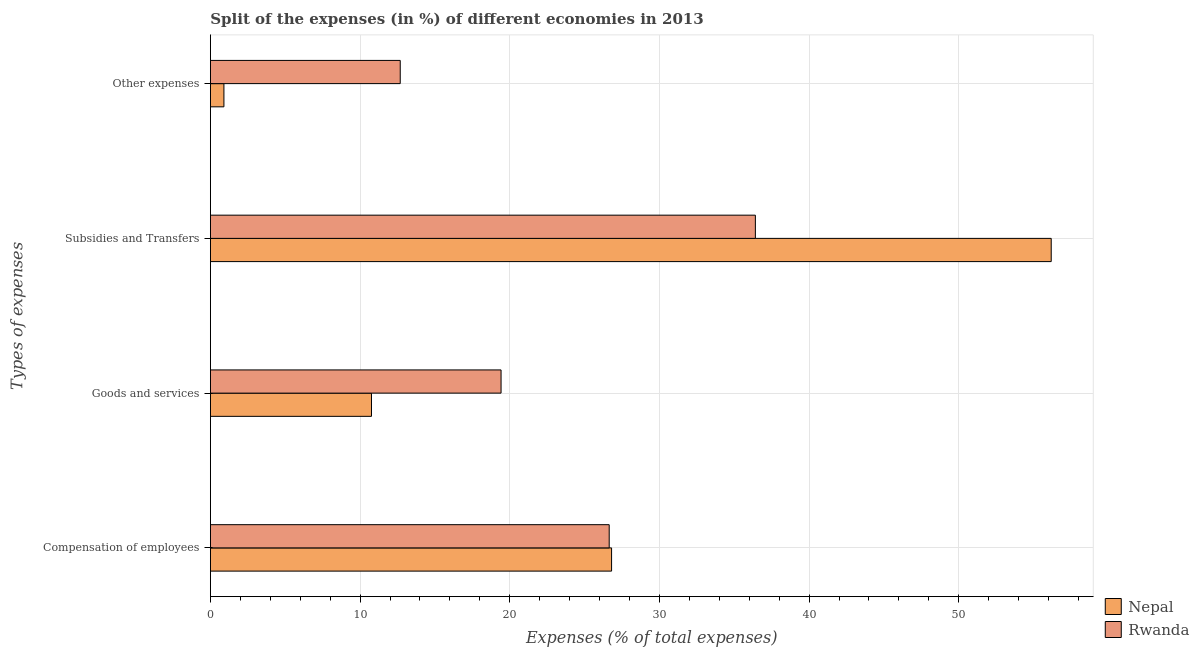Are the number of bars on each tick of the Y-axis equal?
Offer a terse response. Yes. How many bars are there on the 4th tick from the top?
Give a very brief answer. 2. What is the label of the 2nd group of bars from the top?
Your answer should be very brief. Subsidies and Transfers. What is the percentage of amount spent on other expenses in Nepal?
Your answer should be compact. 0.9. Across all countries, what is the maximum percentage of amount spent on subsidies?
Keep it short and to the point. 56.17. Across all countries, what is the minimum percentage of amount spent on subsidies?
Keep it short and to the point. 36.41. In which country was the percentage of amount spent on compensation of employees maximum?
Keep it short and to the point. Nepal. In which country was the percentage of amount spent on subsidies minimum?
Offer a terse response. Rwanda. What is the total percentage of amount spent on subsidies in the graph?
Your response must be concise. 92.58. What is the difference between the percentage of amount spent on compensation of employees in Rwanda and that in Nepal?
Give a very brief answer. -0.16. What is the difference between the percentage of amount spent on compensation of employees in Rwanda and the percentage of amount spent on subsidies in Nepal?
Provide a short and direct response. -29.53. What is the average percentage of amount spent on subsidies per country?
Ensure brevity in your answer.  46.29. What is the difference between the percentage of amount spent on goods and services and percentage of amount spent on compensation of employees in Rwanda?
Offer a very short reply. -7.23. In how many countries, is the percentage of amount spent on other expenses greater than 48 %?
Give a very brief answer. 0. What is the ratio of the percentage of amount spent on goods and services in Nepal to that in Rwanda?
Make the answer very short. 0.55. Is the percentage of amount spent on compensation of employees in Nepal less than that in Rwanda?
Offer a terse response. No. Is the difference between the percentage of amount spent on goods and services in Nepal and Rwanda greater than the difference between the percentage of amount spent on other expenses in Nepal and Rwanda?
Your response must be concise. Yes. What is the difference between the highest and the second highest percentage of amount spent on other expenses?
Offer a terse response. 11.78. What is the difference between the highest and the lowest percentage of amount spent on other expenses?
Make the answer very short. 11.78. In how many countries, is the percentage of amount spent on subsidies greater than the average percentage of amount spent on subsidies taken over all countries?
Offer a terse response. 1. Is the sum of the percentage of amount spent on other expenses in Nepal and Rwanda greater than the maximum percentage of amount spent on compensation of employees across all countries?
Provide a short and direct response. No. What does the 2nd bar from the top in Goods and services represents?
Give a very brief answer. Nepal. What does the 2nd bar from the bottom in Compensation of employees represents?
Offer a terse response. Rwanda. Is it the case that in every country, the sum of the percentage of amount spent on compensation of employees and percentage of amount spent on goods and services is greater than the percentage of amount spent on subsidies?
Make the answer very short. No. Are all the bars in the graph horizontal?
Your response must be concise. Yes. What is the difference between two consecutive major ticks on the X-axis?
Offer a terse response. 10. Are the values on the major ticks of X-axis written in scientific E-notation?
Keep it short and to the point. No. Where does the legend appear in the graph?
Offer a very short reply. Bottom right. What is the title of the graph?
Make the answer very short. Split of the expenses (in %) of different economies in 2013. Does "Lower middle income" appear as one of the legend labels in the graph?
Provide a succinct answer. No. What is the label or title of the X-axis?
Provide a short and direct response. Expenses (% of total expenses). What is the label or title of the Y-axis?
Your answer should be very brief. Types of expenses. What is the Expenses (% of total expenses) in Nepal in Compensation of employees?
Your answer should be compact. 26.8. What is the Expenses (% of total expenses) of Rwanda in Compensation of employees?
Provide a succinct answer. 26.64. What is the Expenses (% of total expenses) of Nepal in Goods and services?
Ensure brevity in your answer.  10.76. What is the Expenses (% of total expenses) in Rwanda in Goods and services?
Offer a terse response. 19.42. What is the Expenses (% of total expenses) in Nepal in Subsidies and Transfers?
Provide a short and direct response. 56.17. What is the Expenses (% of total expenses) of Rwanda in Subsidies and Transfers?
Your response must be concise. 36.41. What is the Expenses (% of total expenses) in Nepal in Other expenses?
Your answer should be very brief. 0.9. What is the Expenses (% of total expenses) of Rwanda in Other expenses?
Offer a very short reply. 12.68. Across all Types of expenses, what is the maximum Expenses (% of total expenses) of Nepal?
Your response must be concise. 56.17. Across all Types of expenses, what is the maximum Expenses (% of total expenses) in Rwanda?
Your response must be concise. 36.41. Across all Types of expenses, what is the minimum Expenses (% of total expenses) of Nepal?
Offer a terse response. 0.9. Across all Types of expenses, what is the minimum Expenses (% of total expenses) in Rwanda?
Provide a succinct answer. 12.68. What is the total Expenses (% of total expenses) of Nepal in the graph?
Your response must be concise. 94.65. What is the total Expenses (% of total expenses) in Rwanda in the graph?
Ensure brevity in your answer.  95.16. What is the difference between the Expenses (% of total expenses) of Nepal in Compensation of employees and that in Goods and services?
Provide a succinct answer. 16.04. What is the difference between the Expenses (% of total expenses) in Rwanda in Compensation of employees and that in Goods and services?
Provide a short and direct response. 7.23. What is the difference between the Expenses (% of total expenses) of Nepal in Compensation of employees and that in Subsidies and Transfers?
Offer a terse response. -29.37. What is the difference between the Expenses (% of total expenses) in Rwanda in Compensation of employees and that in Subsidies and Transfers?
Make the answer very short. -9.76. What is the difference between the Expenses (% of total expenses) in Nepal in Compensation of employees and that in Other expenses?
Offer a very short reply. 25.9. What is the difference between the Expenses (% of total expenses) in Rwanda in Compensation of employees and that in Other expenses?
Keep it short and to the point. 13.96. What is the difference between the Expenses (% of total expenses) in Nepal in Goods and services and that in Subsidies and Transfers?
Make the answer very short. -45.41. What is the difference between the Expenses (% of total expenses) in Rwanda in Goods and services and that in Subsidies and Transfers?
Offer a terse response. -16.99. What is the difference between the Expenses (% of total expenses) in Nepal in Goods and services and that in Other expenses?
Make the answer very short. 9.86. What is the difference between the Expenses (% of total expenses) of Rwanda in Goods and services and that in Other expenses?
Your response must be concise. 6.74. What is the difference between the Expenses (% of total expenses) in Nepal in Subsidies and Transfers and that in Other expenses?
Give a very brief answer. 55.27. What is the difference between the Expenses (% of total expenses) in Rwanda in Subsidies and Transfers and that in Other expenses?
Provide a short and direct response. 23.73. What is the difference between the Expenses (% of total expenses) in Nepal in Compensation of employees and the Expenses (% of total expenses) in Rwanda in Goods and services?
Your response must be concise. 7.38. What is the difference between the Expenses (% of total expenses) in Nepal in Compensation of employees and the Expenses (% of total expenses) in Rwanda in Subsidies and Transfers?
Provide a short and direct response. -9.61. What is the difference between the Expenses (% of total expenses) of Nepal in Compensation of employees and the Expenses (% of total expenses) of Rwanda in Other expenses?
Your answer should be compact. 14.12. What is the difference between the Expenses (% of total expenses) in Nepal in Goods and services and the Expenses (% of total expenses) in Rwanda in Subsidies and Transfers?
Offer a very short reply. -25.65. What is the difference between the Expenses (% of total expenses) in Nepal in Goods and services and the Expenses (% of total expenses) in Rwanda in Other expenses?
Keep it short and to the point. -1.92. What is the difference between the Expenses (% of total expenses) of Nepal in Subsidies and Transfers and the Expenses (% of total expenses) of Rwanda in Other expenses?
Your response must be concise. 43.49. What is the average Expenses (% of total expenses) of Nepal per Types of expenses?
Your response must be concise. 23.66. What is the average Expenses (% of total expenses) of Rwanda per Types of expenses?
Provide a succinct answer. 23.79. What is the difference between the Expenses (% of total expenses) of Nepal and Expenses (% of total expenses) of Rwanda in Compensation of employees?
Keep it short and to the point. 0.16. What is the difference between the Expenses (% of total expenses) of Nepal and Expenses (% of total expenses) of Rwanda in Goods and services?
Your answer should be very brief. -8.66. What is the difference between the Expenses (% of total expenses) of Nepal and Expenses (% of total expenses) of Rwanda in Subsidies and Transfers?
Your response must be concise. 19.77. What is the difference between the Expenses (% of total expenses) in Nepal and Expenses (% of total expenses) in Rwanda in Other expenses?
Offer a very short reply. -11.78. What is the ratio of the Expenses (% of total expenses) of Nepal in Compensation of employees to that in Goods and services?
Keep it short and to the point. 2.49. What is the ratio of the Expenses (% of total expenses) of Rwanda in Compensation of employees to that in Goods and services?
Ensure brevity in your answer.  1.37. What is the ratio of the Expenses (% of total expenses) of Nepal in Compensation of employees to that in Subsidies and Transfers?
Your answer should be very brief. 0.48. What is the ratio of the Expenses (% of total expenses) in Rwanda in Compensation of employees to that in Subsidies and Transfers?
Your answer should be very brief. 0.73. What is the ratio of the Expenses (% of total expenses) in Nepal in Compensation of employees to that in Other expenses?
Keep it short and to the point. 29.63. What is the ratio of the Expenses (% of total expenses) in Rwanda in Compensation of employees to that in Other expenses?
Offer a very short reply. 2.1. What is the ratio of the Expenses (% of total expenses) in Nepal in Goods and services to that in Subsidies and Transfers?
Keep it short and to the point. 0.19. What is the ratio of the Expenses (% of total expenses) of Rwanda in Goods and services to that in Subsidies and Transfers?
Ensure brevity in your answer.  0.53. What is the ratio of the Expenses (% of total expenses) in Nepal in Goods and services to that in Other expenses?
Give a very brief answer. 11.9. What is the ratio of the Expenses (% of total expenses) in Rwanda in Goods and services to that in Other expenses?
Offer a terse response. 1.53. What is the ratio of the Expenses (% of total expenses) in Nepal in Subsidies and Transfers to that in Other expenses?
Provide a succinct answer. 62.09. What is the ratio of the Expenses (% of total expenses) of Rwanda in Subsidies and Transfers to that in Other expenses?
Offer a very short reply. 2.87. What is the difference between the highest and the second highest Expenses (% of total expenses) of Nepal?
Provide a short and direct response. 29.37. What is the difference between the highest and the second highest Expenses (% of total expenses) of Rwanda?
Your response must be concise. 9.76. What is the difference between the highest and the lowest Expenses (% of total expenses) of Nepal?
Ensure brevity in your answer.  55.27. What is the difference between the highest and the lowest Expenses (% of total expenses) of Rwanda?
Offer a very short reply. 23.73. 